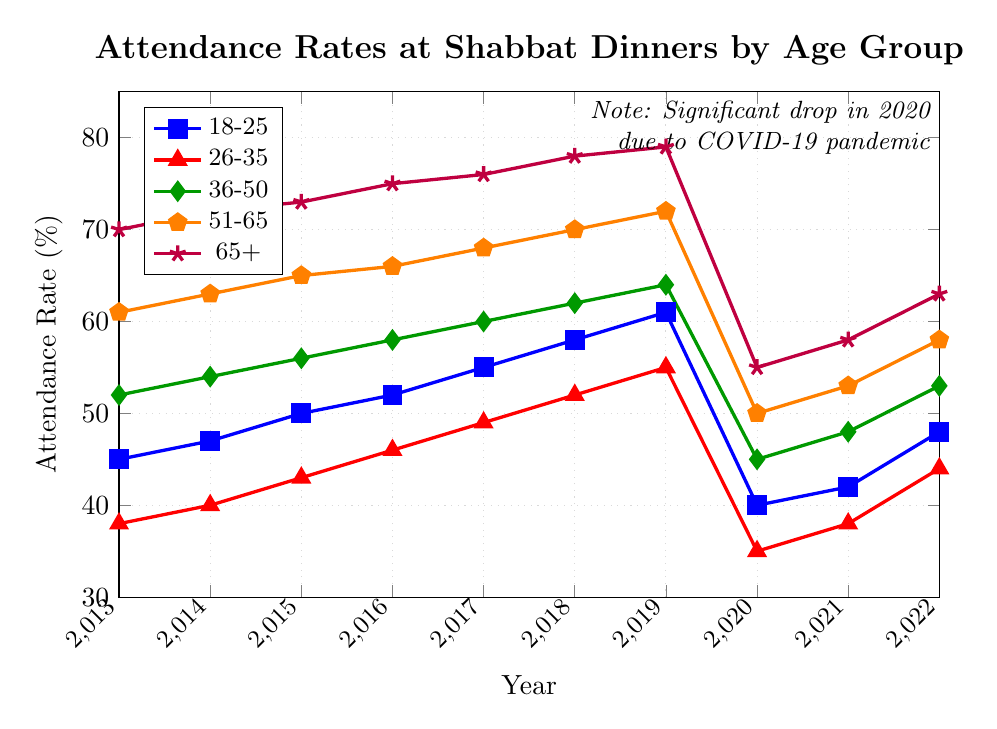Which age group has the highest attendance rate in 2017? The highest attendance rate in 2017 is the data point that is visually the highest on the plot for that year. Referring to the figure, the purple line (65+) has the highest point at 76%.
Answer: 65+ How did the attendance rate for the 18-25 age group change from 2019 to 2020? To determine the change, calculate the difference between the 2019 and 2020 attendance rates for the 18-25 age group. The attendance rate in 2019 was 61%, and in 2020 it was 40%. The difference is 61% - 40% = 21%.
Answer: Decreased by 21% What was the average attendance rate for the 36-50 age group over the last decade? To find the average, sum the attendance rates for the 36-50 age group from 2013 to 2022 and divide by the number of years (10). The sum is 52+54+56+58+60+62+64+45+48+53 = 552. The average is 552 / 10 = 55.2%.
Answer: 55.2% Which age group experienced the largest drop in attendance rate in 2020? The largest drop is found by comparing the differences in attendance between 2019 and 2020 for each age group. Calculate the differences: 
18-25: 61 - 40 = 21, 
26-35: 55 - 35 = 20, 
36-50: 64 - 45 = 19, 
51-65: 72 - 50 = 22, 
65+: 79 - 55 = 24. 
The largest drop is 24 for the 65+ group.
Answer: 65+ By how much did the attendance rate for the 18-25 age group increase from 2020 to 2022? Calculate the difference in attendance rates between 2020 and 2022 for the 18-25 age group. The attendance rate in 2020 was 40% and in 2022 it was 48%. The increase is 48% - 40% = 8%.
Answer: Increased by 8% What trend do you observe in the attendance rates of the 26-35 age group from 2013 to 2019? Observing the line plot for the 26-35 age group from 2013 to 2019, the rate shows a consistent upward trend. It starts at 38% in 2013 and rises to 55% in 2019.
Answer: Upward trend Which two age groups showed the closest attendance rates in 2014, and what were those rates? To find the closest attendance rates in 2014, visually compare the values: 
18-25: 47%, 
26-35: 40%, 
36-50: 54%, 
51-65: 63%, 
65+: 72%. 
The 36-50 and 51-65 groups are closest with rates of 54% and 63%.
Answer: 36-50 (54%) and 51-65 (63%) What was the lowest attendance rate observed across all age groups and years in the plot? The lowest point across all age groups and years in the plot is at 35% for the 26-35 age group in 2020.
Answer: 35% How many years did the attendance rate for the 51-65 age group increase consecutively before 2020? The attendance rate for the 51-65 age group increases every year from 2013 (61%) to 2019 (72%), giving six consecutive years of increase before 2020.
Answer: Six years What was the difference in attendance rates between the 36-50 and the 65+ age groups in 2019? Calculate the difference in attendance rates in 2019 between the 36-50 age group (64%) and the 65+ age group (79%). The difference is 79% - 64% = 15%.
Answer: 15% 